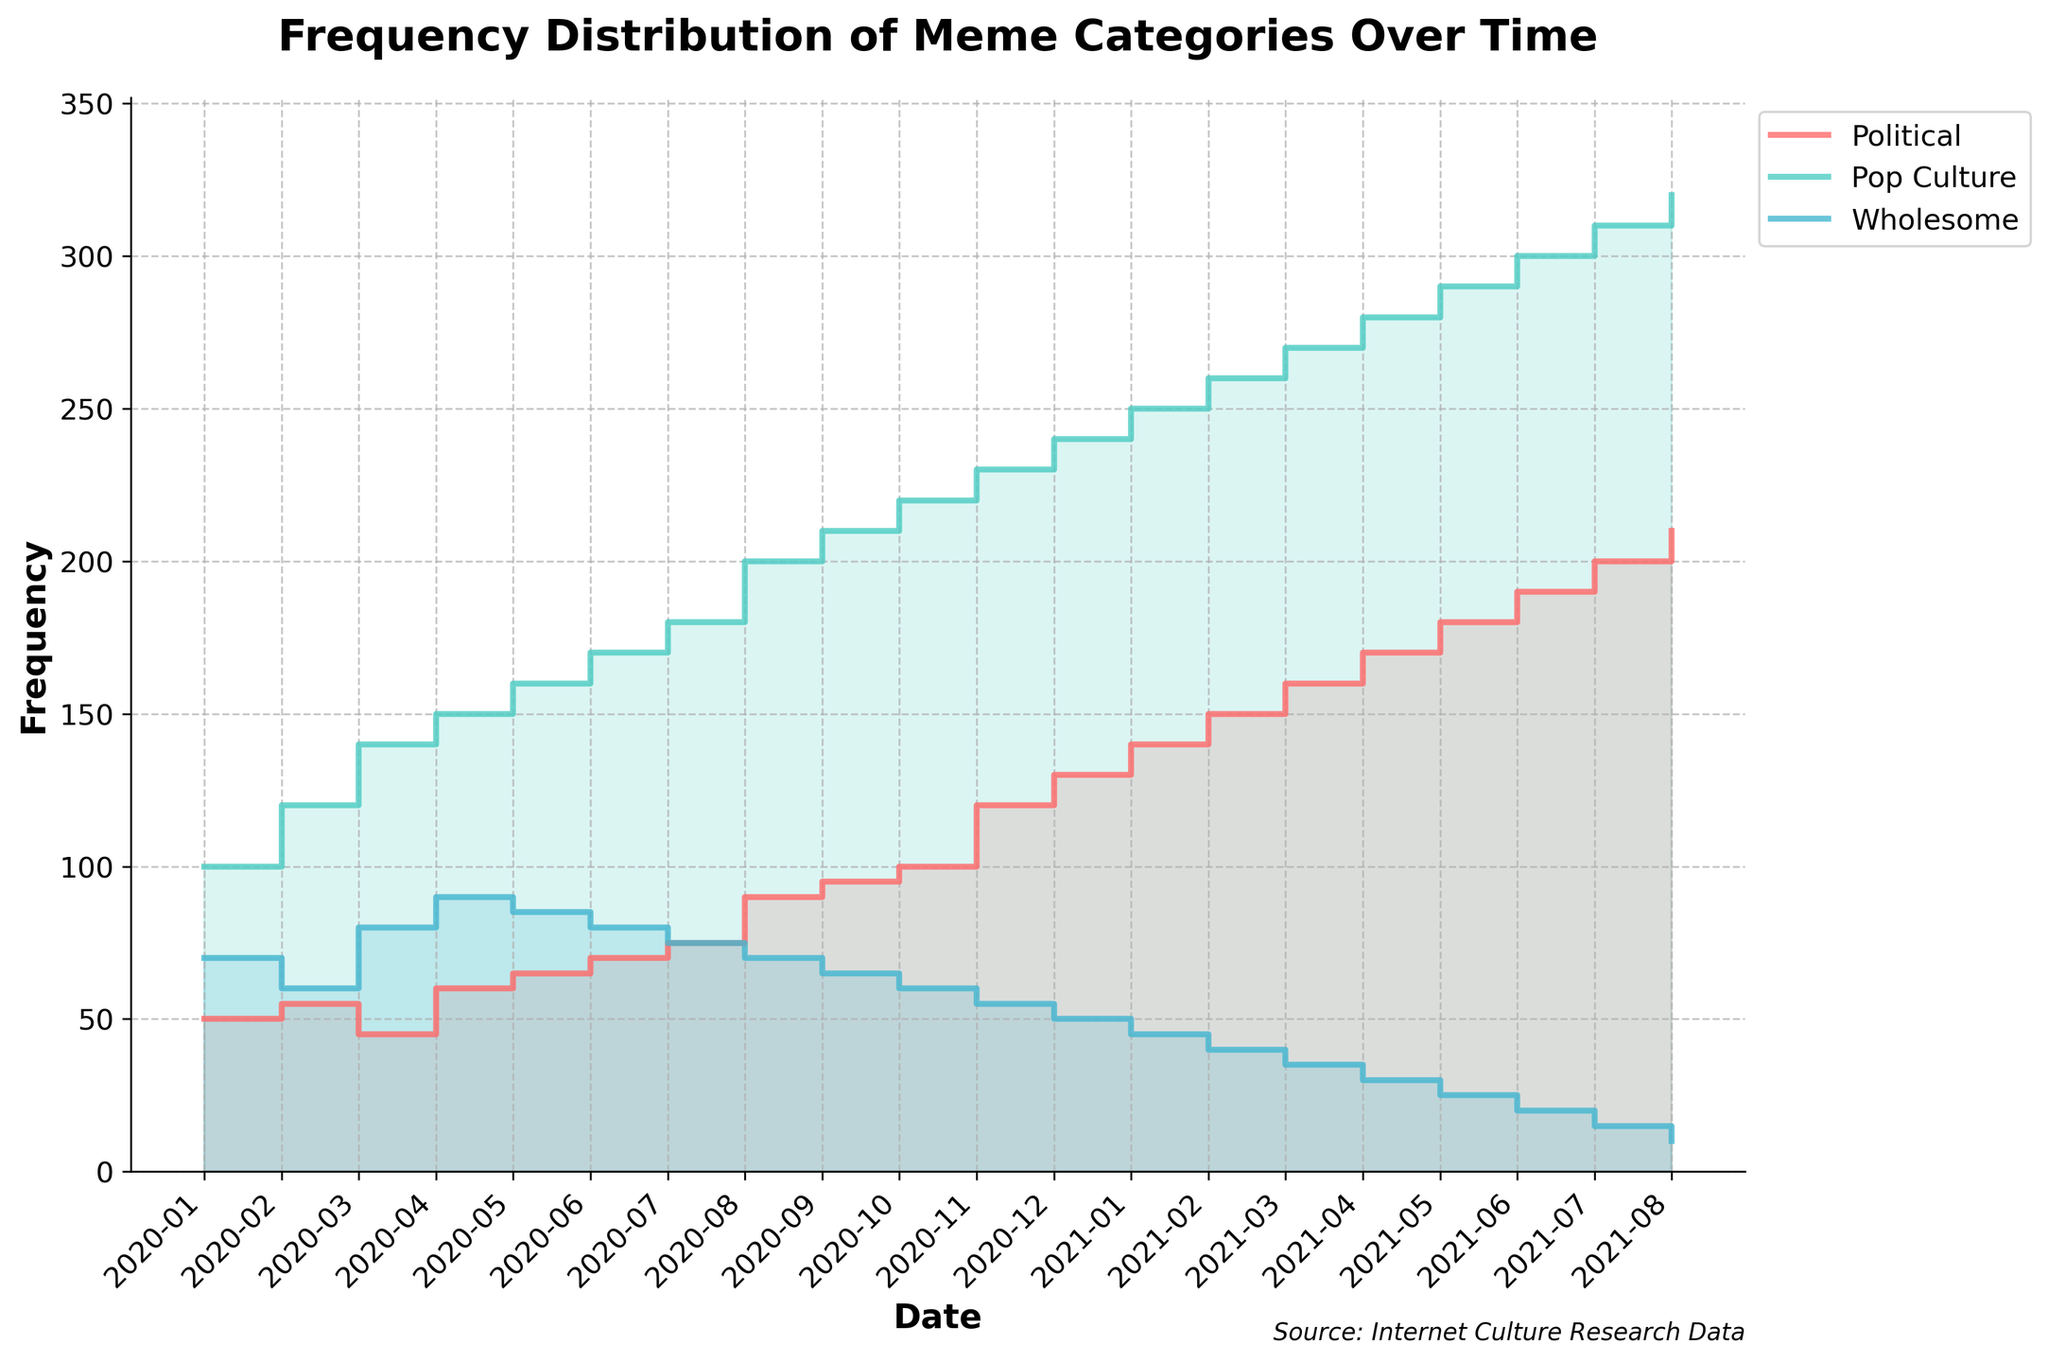What is the title of the figure? The title of the figure is usually located at the top and indicates what the plot is about.
Answer: Frequency Distribution of Meme Categories Over Time What does the x-axis represent? The x-axis labels are dates, indicating the time period over which the meme categories are plotted.
Answer: Date What does the y-axis represent? The y-axis is labeled "Frequency," showing the frequency of memes in each category over time.
Answer: Frequency Which meme category has the highest frequency in August 2020? In the figure, finding the point corresponding to August 2020 and comparing the values for Political, Pop Culture, and Wholesome will reveal the highest frequency.
Answer: Pop Culture Compare the frequency of Political memes in January 2020 and January 2021. The given frequencies are: January 2020 - 50, January 2021 - 140. Subtracting these values shows the increase.
Answer: 90 By how much did the frequency of Wholesome memes change from February 2020 to February 2021? Identifying the frequencies in February 2020 (60) and February 2021 (40) and calculating the difference shows the change.
Answer: -20 Which category shows a decline in frequency over the entire period? Looking at the overall trend lines, the Wholesome category shows a consistent decline.
Answer: Wholesome What is the trend for Pop Culture memes over time? Observing the Pop Culture line from January 2020 to August 2021, the trend is a rising frequency.
Answer: Increasing At what month does the Political category first surpass 100 in frequency? Finding the first point where the Political line crosses the 100 mark is October 2020.
Answer: October 2020 What is the difference in frequency between Pop Culture and Political memes in December 2020? The frequencies in December 2020 are 240 for Pop Culture and 130 for Political. Subtracting these gives the difference.
Answer: 110 